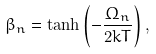<formula> <loc_0><loc_0><loc_500><loc_500>\beta _ { n } = \tanh \left ( - \frac { \Omega _ { n } } { 2 k T } \right ) ,</formula> 